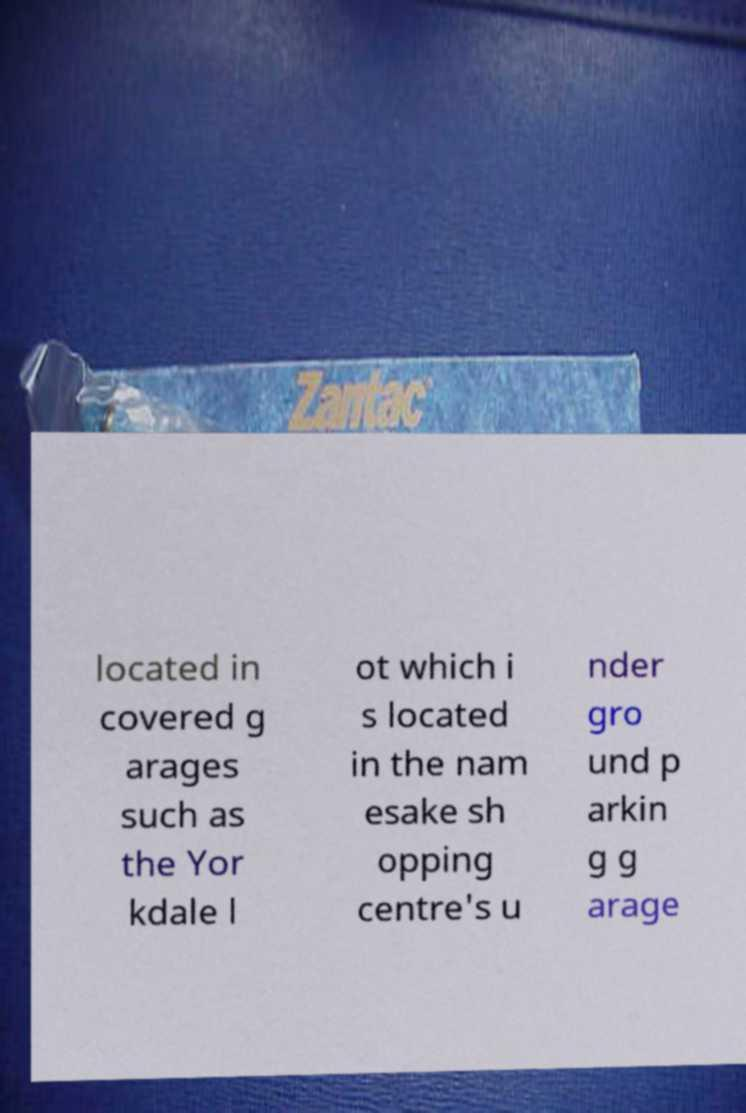I need the written content from this picture converted into text. Can you do that? located in covered g arages such as the Yor kdale l ot which i s located in the nam esake sh opping centre's u nder gro und p arkin g g arage 